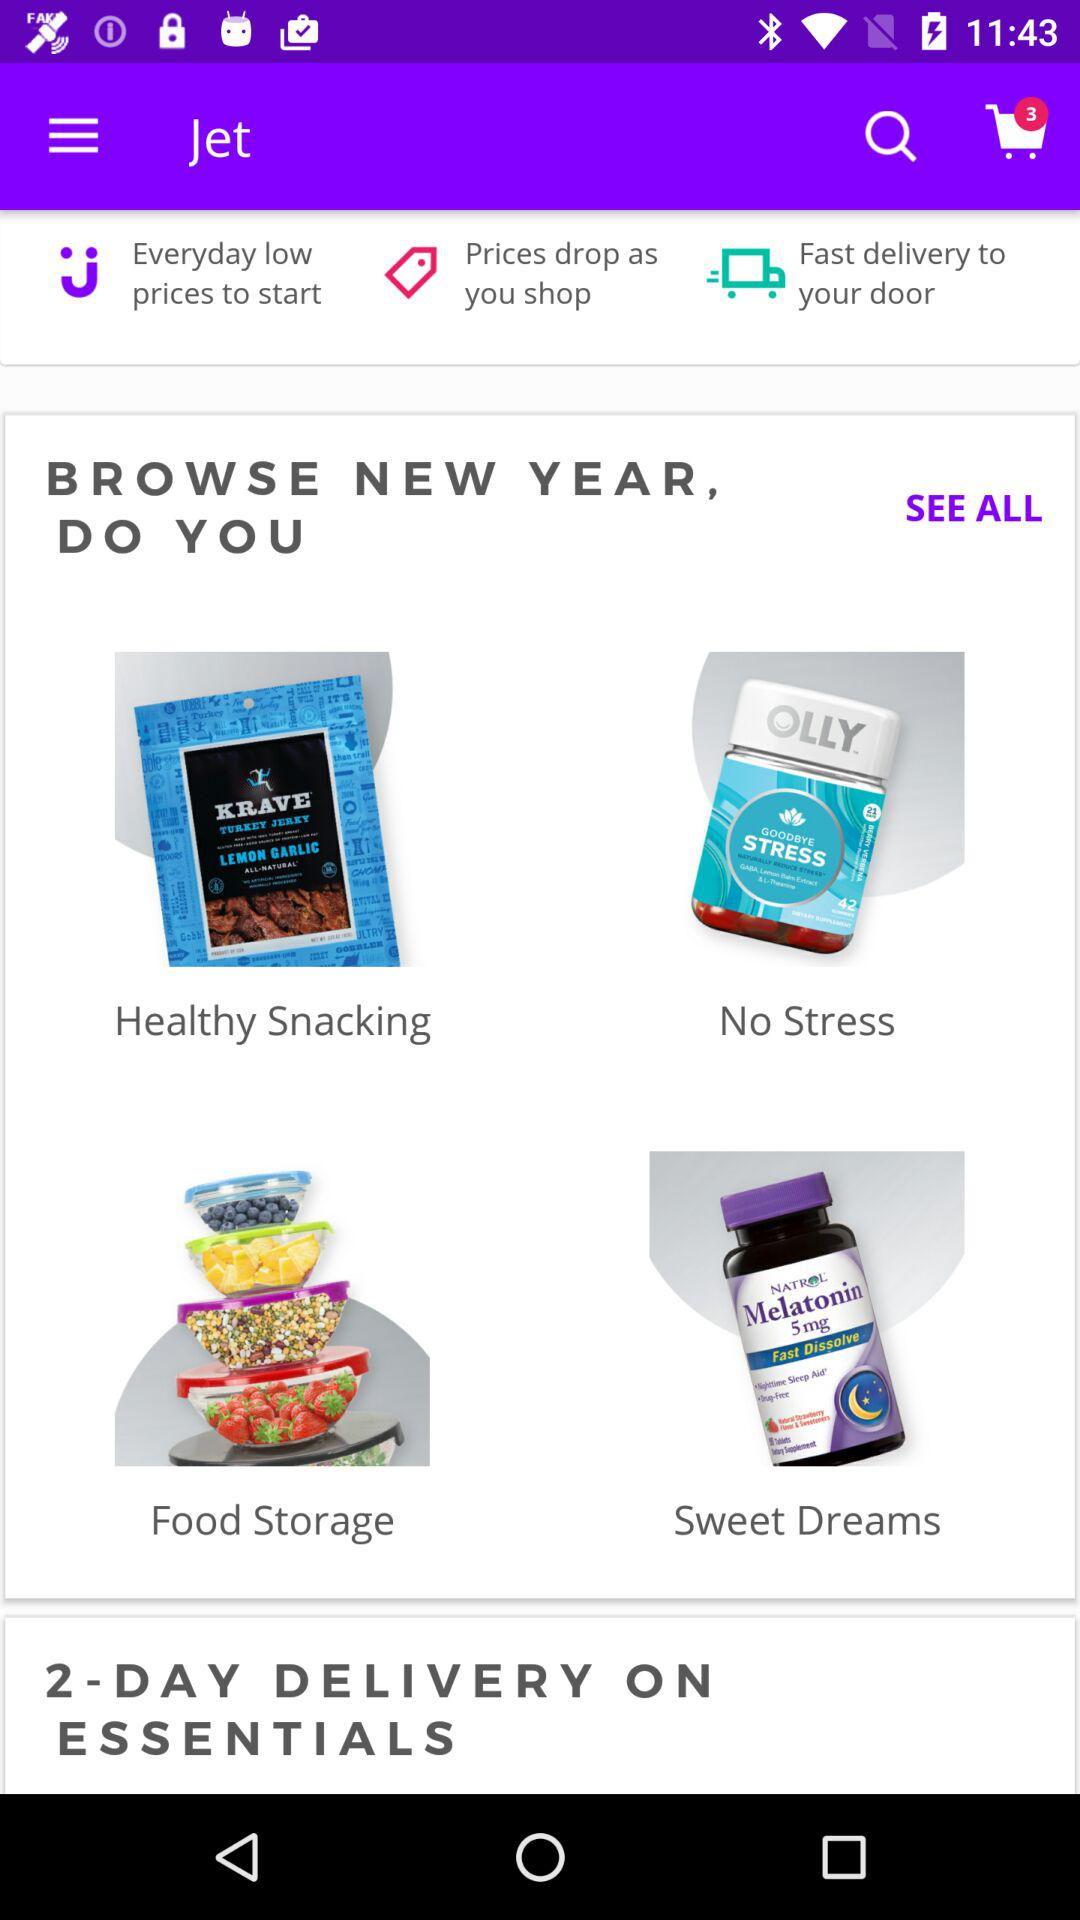How many items are in the cart?
Answer the question using a single word or phrase. 3 